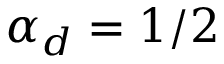<formula> <loc_0><loc_0><loc_500><loc_500>\alpha _ { d } = 1 / 2</formula> 